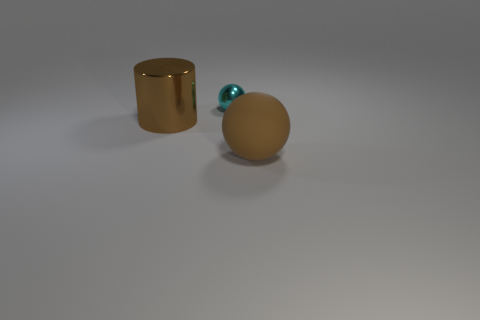Is there anything else that is the same size as the cyan object?
Make the answer very short. No. There is a object that is both right of the big cylinder and to the left of the brown rubber thing; what size is it?
Offer a terse response. Small. Are there any objects in front of the cyan thing?
Ensure brevity in your answer.  Yes. How many things are brown objects that are on the left side of the large brown matte sphere or large brown things?
Offer a very short reply. 2. How many metallic things are in front of the small shiny object behind the brown sphere?
Keep it short and to the point. 1. Are there fewer brown metal things in front of the brown shiny cylinder than brown shiny cylinders that are behind the tiny cyan object?
Ensure brevity in your answer.  No. There is a large brown thing that is in front of the big object on the left side of the rubber ball; what shape is it?
Ensure brevity in your answer.  Sphere. What number of other things are the same material as the large sphere?
Keep it short and to the point. 0. Are there more big metal things than big gray cylinders?
Ensure brevity in your answer.  Yes. How big is the object in front of the brown object on the left side of the tiny cyan metallic sphere behind the big matte thing?
Make the answer very short. Large. 